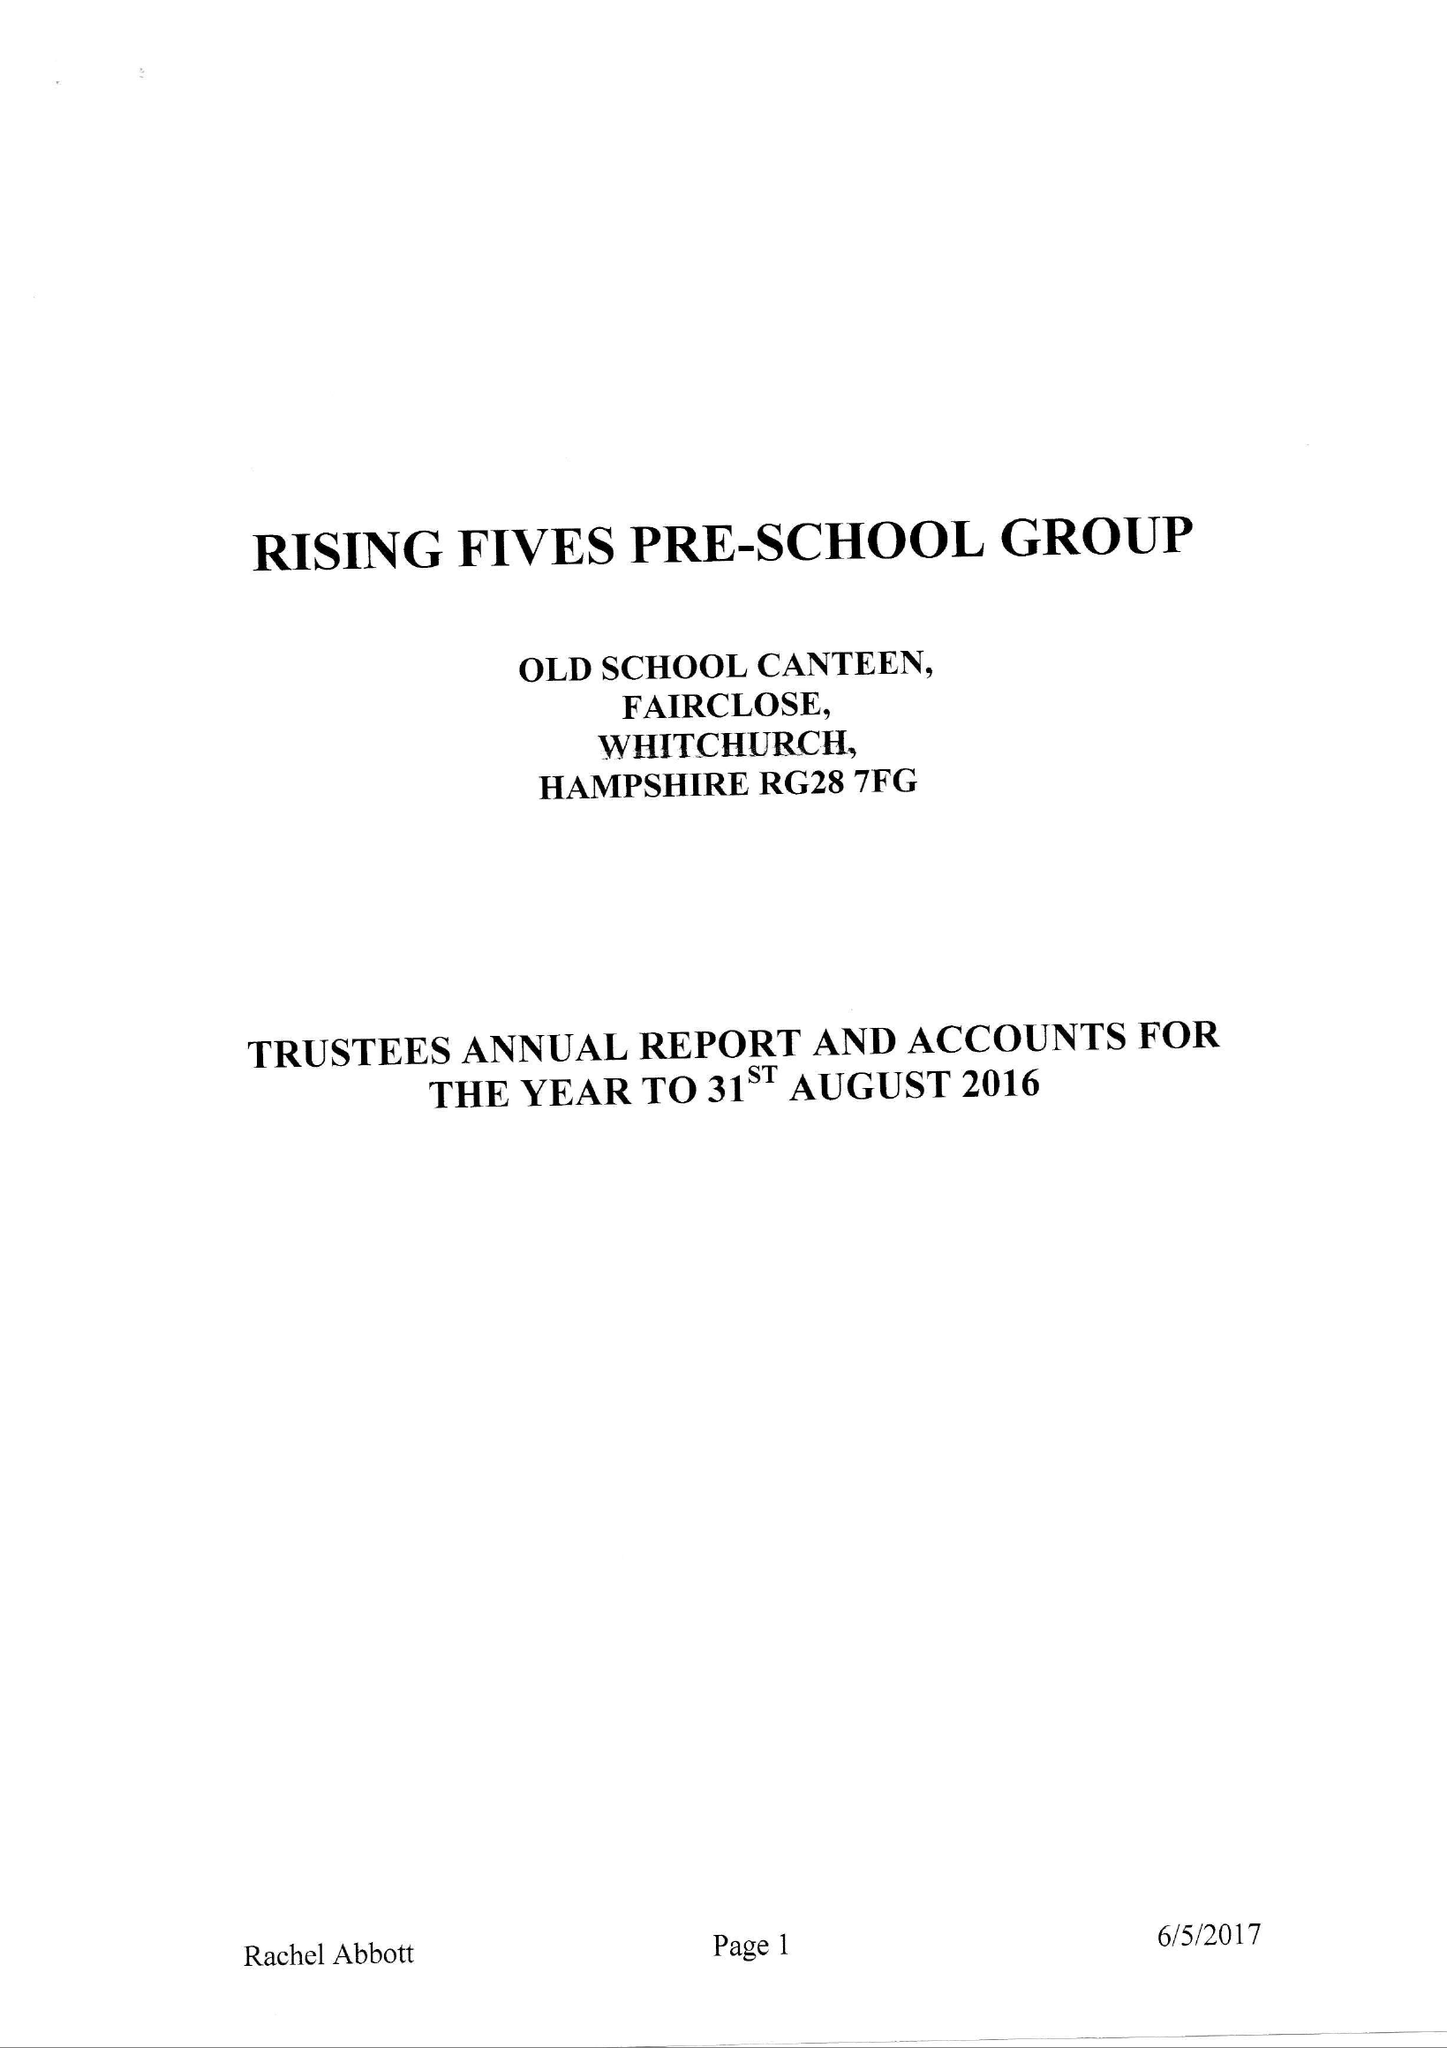What is the value for the report_date?
Answer the question using a single word or phrase. 2016-08-31 